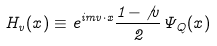Convert formula to latex. <formula><loc_0><loc_0><loc_500><loc_500>H _ { v } ( x ) \equiv e ^ { i m v \cdot x } \frac { 1 - \not { v } } { 2 } \Psi _ { Q } ( x )</formula> 